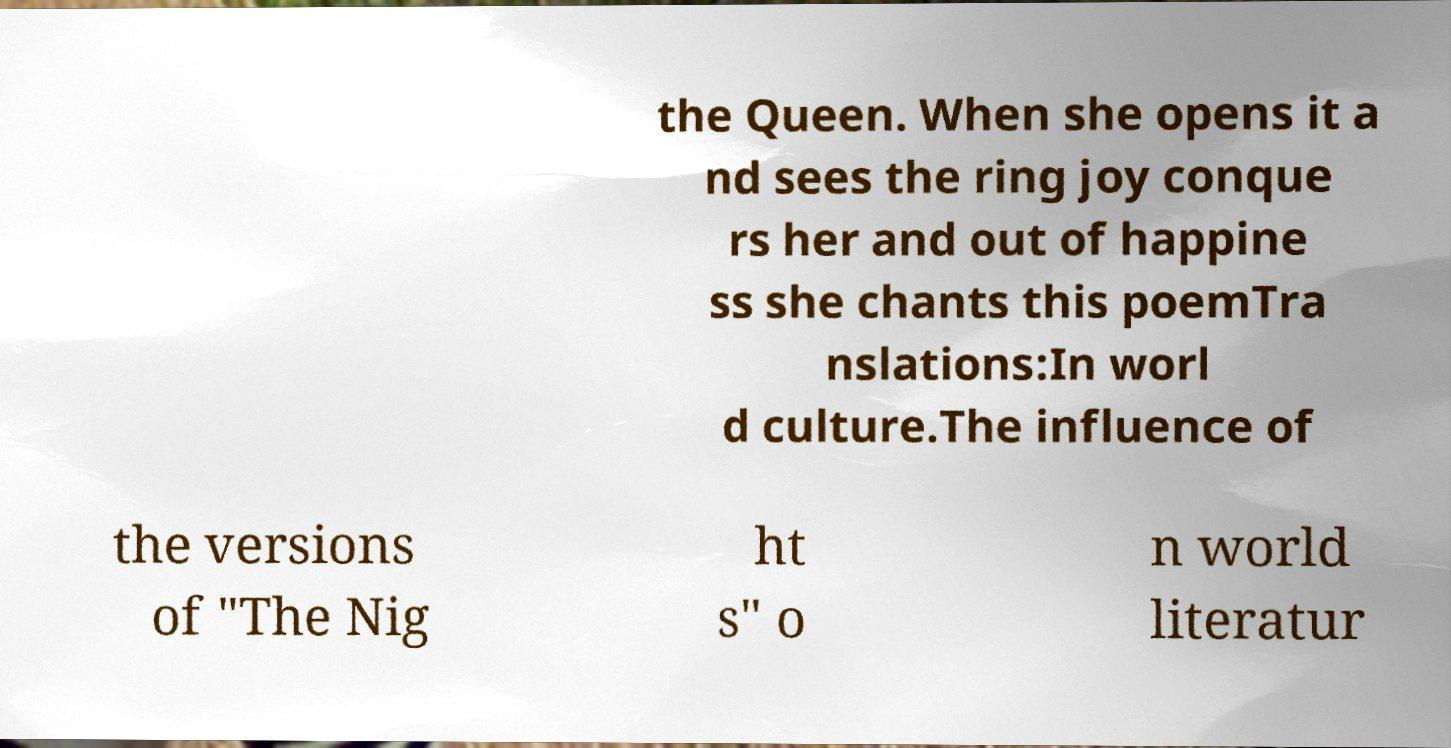Please read and relay the text visible in this image. What does it say? the Queen. When she opens it a nd sees the ring joy conque rs her and out of happine ss she chants this poemTra nslations:In worl d culture.The influence of the versions of "The Nig ht s" o n world literatur 